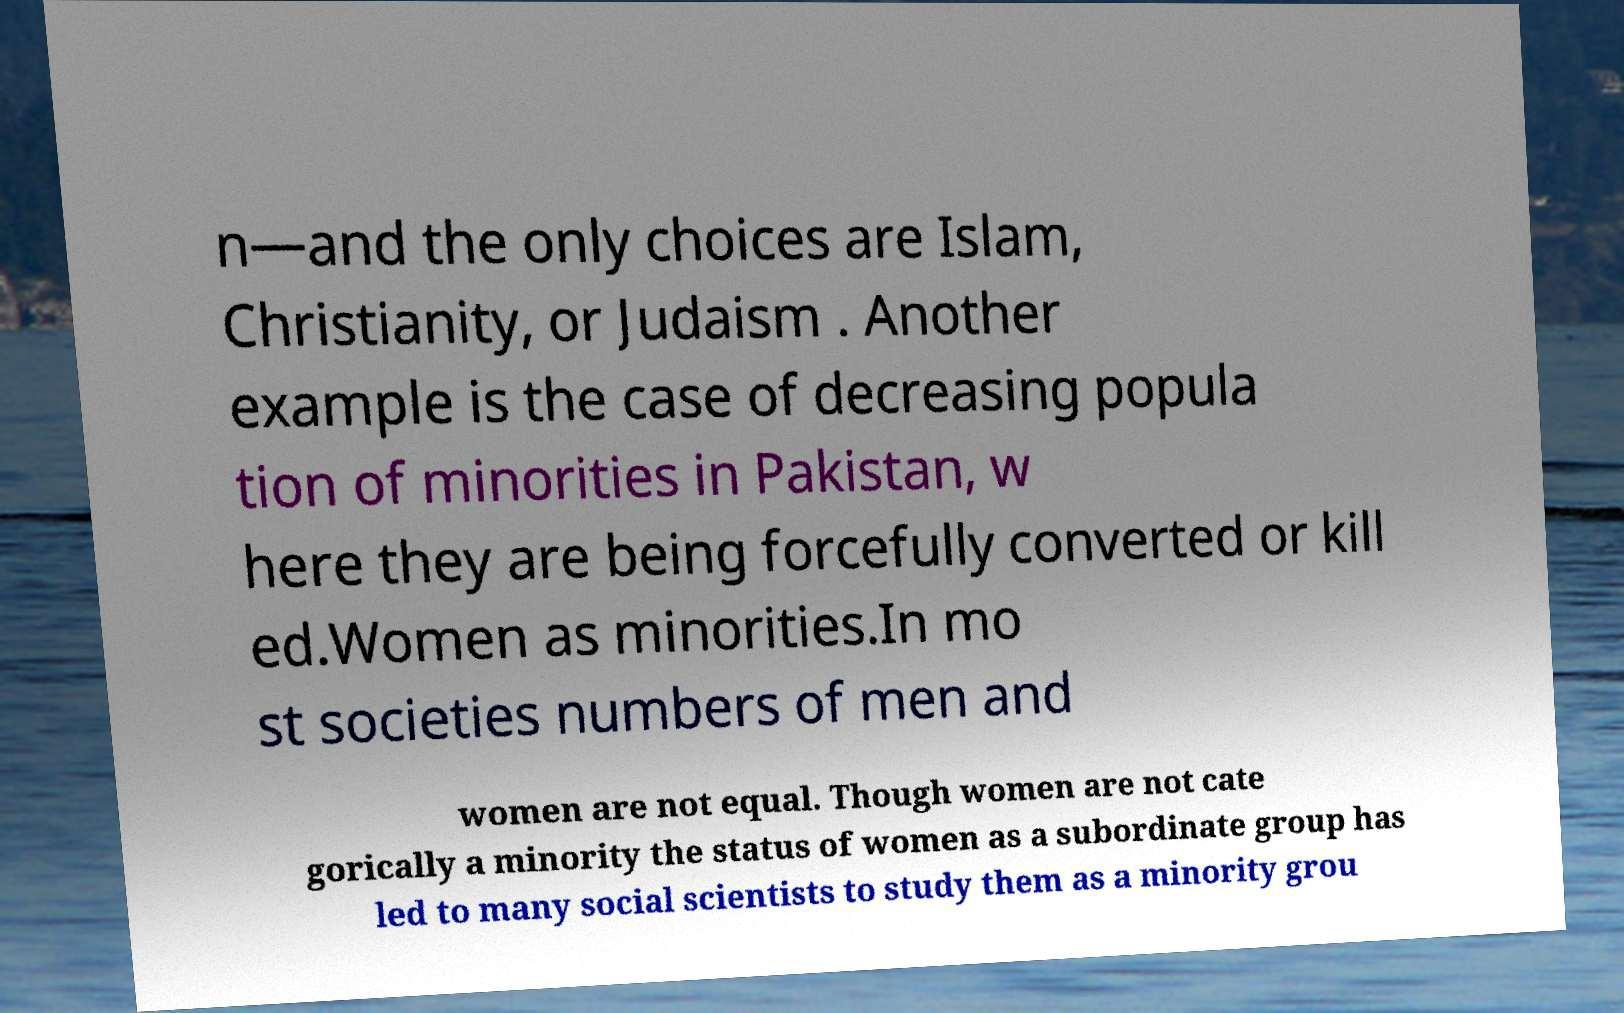Please read and relay the text visible in this image. What does it say? n—and the only choices are Islam, Christianity, or Judaism . Another example is the case of decreasing popula tion of minorities in Pakistan, w here they are being forcefully converted or kill ed.Women as minorities.In mo st societies numbers of men and women are not equal. Though women are not cate gorically a minority the status of women as a subordinate group has led to many social scientists to study them as a minority grou 